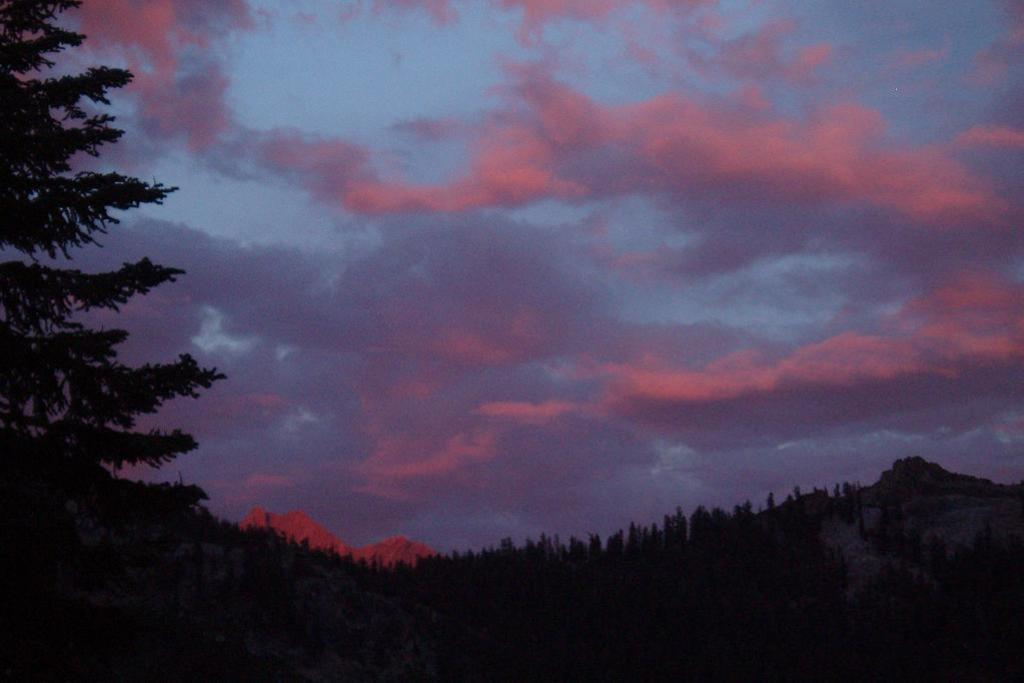What type of vegetation can be seen in the image? There are trees in the image, extending from left to right. What is the condition of the sky in the image? The sky is cloudy in the image. What type of title is visible on the clam in the image? There is no clam or title present in the image; it features trees and a cloudy sky. Is there a beggar visible in the image? There is no beggar present in the image; it features trees and a cloudy sky. 